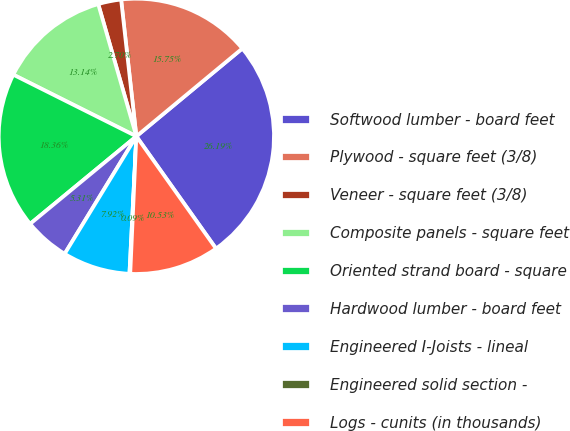Convert chart. <chart><loc_0><loc_0><loc_500><loc_500><pie_chart><fcel>Softwood lumber - board feet<fcel>Plywood - square feet (3/8)<fcel>Veneer - square feet (3/8)<fcel>Composite panels - square feet<fcel>Oriented strand board - square<fcel>Hardwood lumber - board feet<fcel>Engineered I-Joists - lineal<fcel>Engineered solid section -<fcel>Logs - cunits (in thousands)<nl><fcel>26.19%<fcel>15.75%<fcel>2.7%<fcel>13.14%<fcel>18.36%<fcel>5.31%<fcel>7.92%<fcel>0.09%<fcel>10.53%<nl></chart> 